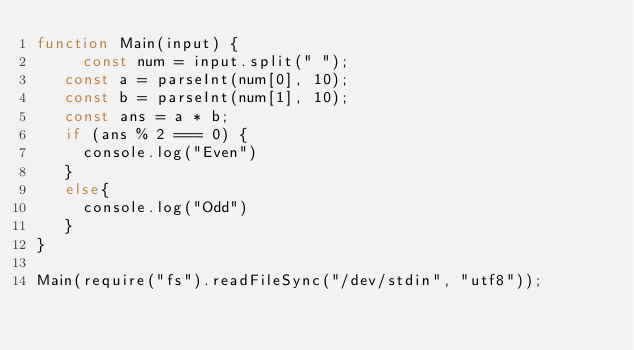<code> <loc_0><loc_0><loc_500><loc_500><_JavaScript_>function Main(input) {
	 const num = input.split(" ");
   const a = parseInt(num[0], 10);
   const b = parseInt(num[1], 10);
   const ans = a * b;
   if (ans % 2 === 0) {
     console.log("Even")
   }
   else{
     console.log("Odd")
   }
}

Main(require("fs").readFileSync("/dev/stdin", "utf8"));
</code> 